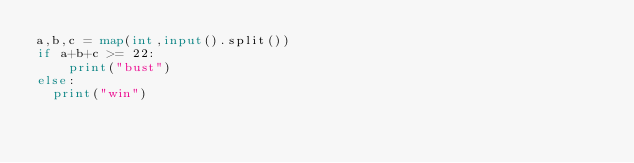Convert code to text. <code><loc_0><loc_0><loc_500><loc_500><_Python_>a,b,c = map(int,input().split())
if a+b+c >= 22:
  	print("bust")
else:
  print("win")</code> 